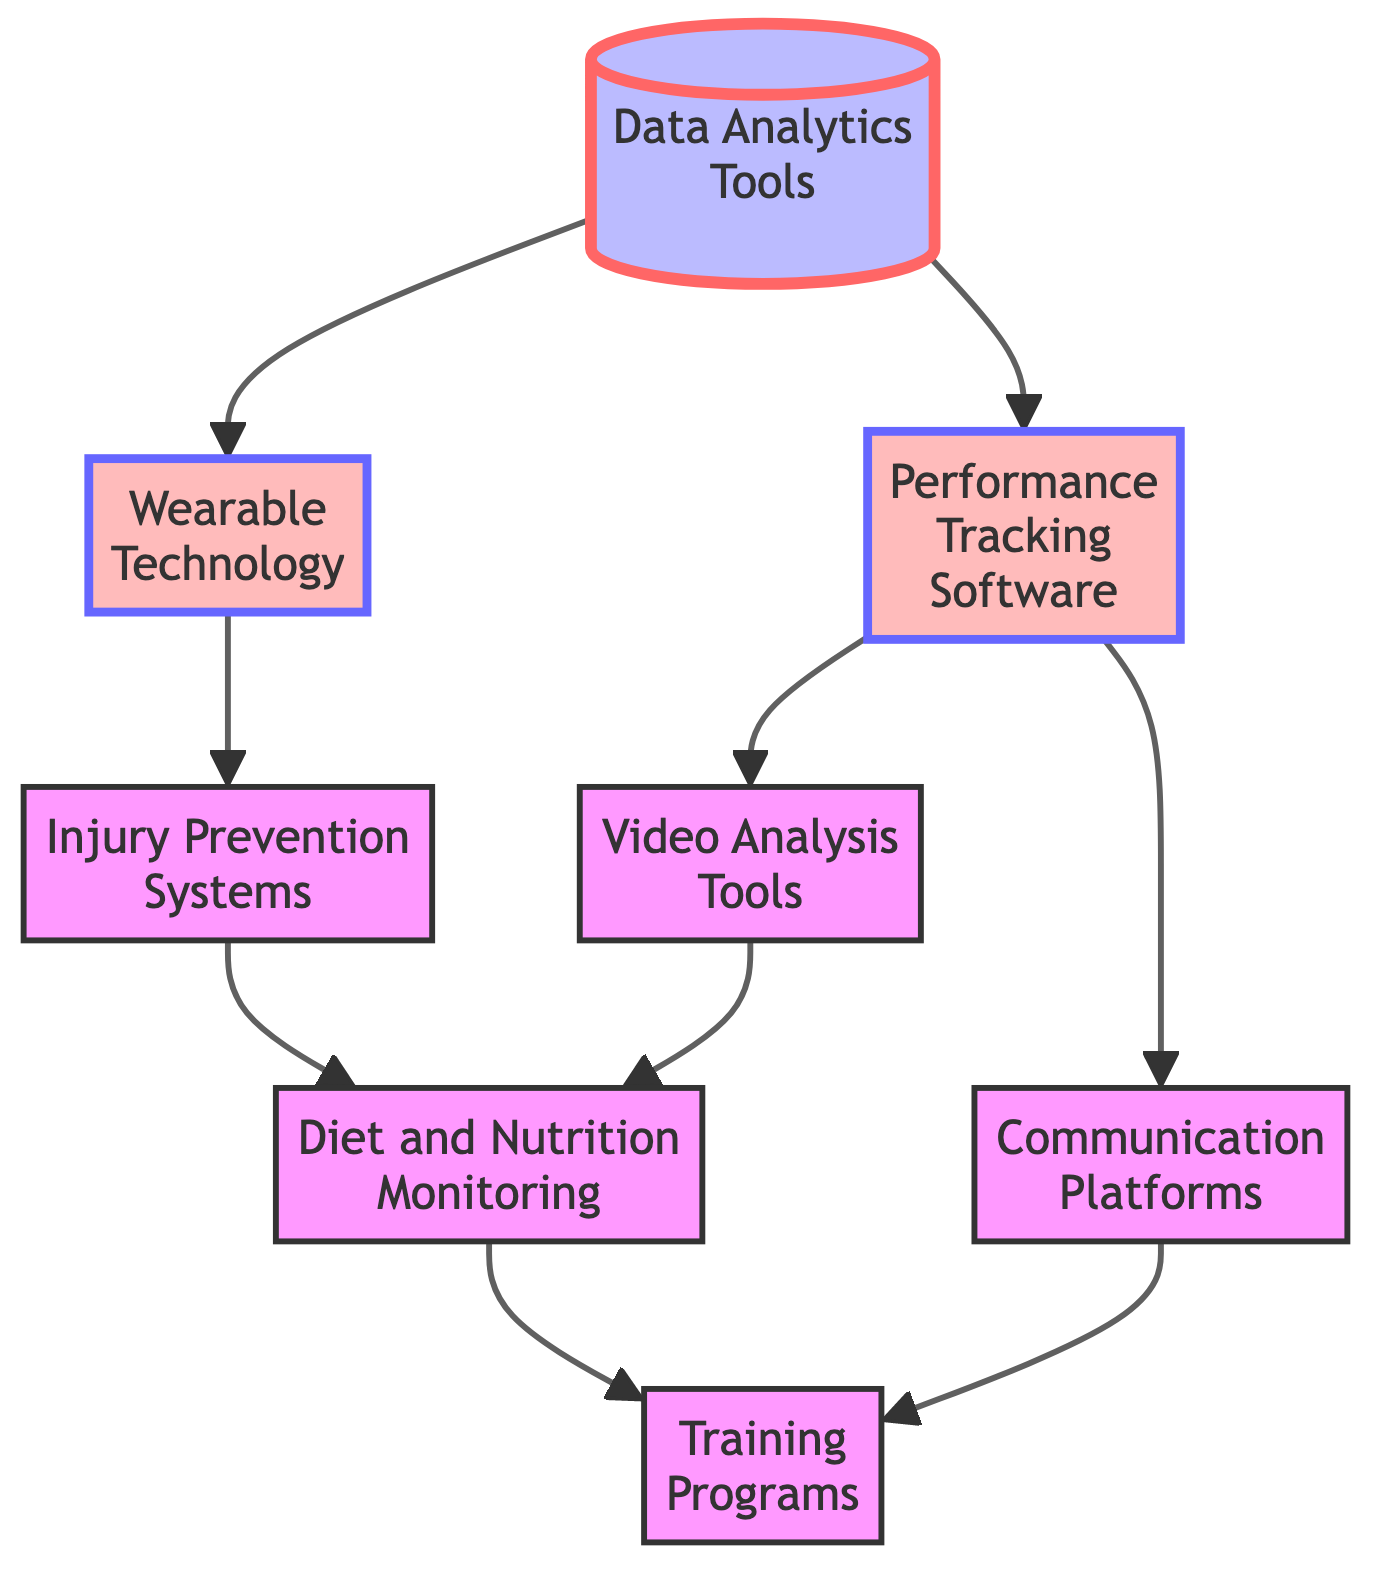What is the title of the diagram? The title of the diagram is explicitly mentioned as "Technological Advancements and Their Impact on Team Performance."
Answer: Technological Advancements and Their Impact on Team Performance How many nodes are there in the diagram? Counting all unique blocks listed in the data, there are a total of 8 nodes in the diagram.
Answer: 8 Which block is connected to Performance Tracking Software? According to the connections indicated, Performance Tracking Software is connected to Video Analysis Tools and Communication Platforms.
Answer: Video Analysis Tools, Communication Platforms What is the connection between Wearable Technology and Injury Prevention Systems? Wearable Technology is directly connected to Injury Prevention Systems through the flow of data tracking health metrics that predict injuries.
Answer: Yes Which block has the final result in the diagram? The arrow connections indicate that Training Programs is the last output or endpoint of the flow in the diagram.
Answer: Training Programs What type of tools are described in the first block? The description of the first block indicates that these are data analytics tools used to improve decision-making and performance monitoring.
Answer: Data Analytics Tools What is the relationship between Communication Platforms and Training Programs? Communication Platforms is connected to Training Programs, demonstrating that effective communication aids in the development of tailored training regimens.
Answer: Direct connection What is the common feature of the blocks after Performance Tracking Software? The blocks following Performance Tracking Software (Video Analysis Tools and Communication Platforms) are both focused on enhancing player performance assessments and team coordination.
Answer: Performance assessment and coordination How many direct connections do the Wearable Technology and Diet and Nutrition Monitoring blocks have? Wearable Technology has one direct connection (to Injury Prevention Systems) while Diet and Nutrition Monitoring has one connection (from both Injury Prevention Systems and Video Analysis Tools) to Training Programs.
Answer: 1 each 